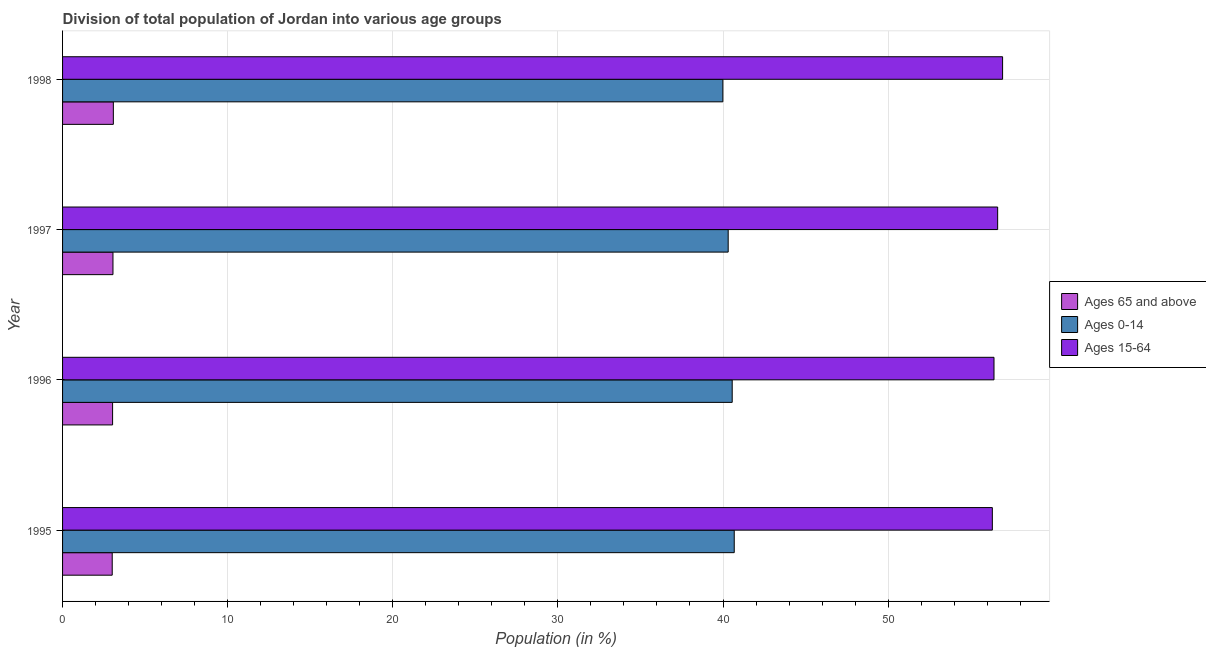Are the number of bars per tick equal to the number of legend labels?
Keep it short and to the point. Yes. Are the number of bars on each tick of the Y-axis equal?
Your answer should be very brief. Yes. How many bars are there on the 1st tick from the top?
Your response must be concise. 3. What is the label of the 1st group of bars from the top?
Your response must be concise. 1998. In how many cases, is the number of bars for a given year not equal to the number of legend labels?
Your response must be concise. 0. What is the percentage of population within the age-group 0-14 in 1995?
Make the answer very short. 40.68. Across all years, what is the maximum percentage of population within the age-group of 65 and above?
Keep it short and to the point. 3.08. Across all years, what is the minimum percentage of population within the age-group 0-14?
Ensure brevity in your answer.  39.99. In which year was the percentage of population within the age-group of 65 and above minimum?
Provide a succinct answer. 1995. What is the total percentage of population within the age-group of 65 and above in the graph?
Offer a terse response. 12.17. What is the difference between the percentage of population within the age-group 0-14 in 1995 and that in 1998?
Offer a very short reply. 0.69. What is the difference between the percentage of population within the age-group of 65 and above in 1996 and the percentage of population within the age-group 15-64 in 1995?
Make the answer very short. -53.28. What is the average percentage of population within the age-group 15-64 per year?
Keep it short and to the point. 56.57. In the year 1996, what is the difference between the percentage of population within the age-group 0-14 and percentage of population within the age-group 15-64?
Offer a terse response. -15.86. In how many years, is the percentage of population within the age-group 0-14 greater than 14 %?
Your answer should be very brief. 4. Is the percentage of population within the age-group 15-64 in 1996 less than that in 1997?
Offer a very short reply. Yes. Is the difference between the percentage of population within the age-group 0-14 in 1995 and 1998 greater than the difference between the percentage of population within the age-group of 65 and above in 1995 and 1998?
Keep it short and to the point. Yes. What is the difference between the highest and the second highest percentage of population within the age-group of 65 and above?
Give a very brief answer. 0.02. What is the difference between the highest and the lowest percentage of population within the age-group 15-64?
Make the answer very short. 0.62. What does the 3rd bar from the top in 1996 represents?
Ensure brevity in your answer.  Ages 65 and above. What does the 2nd bar from the bottom in 1995 represents?
Keep it short and to the point. Ages 0-14. Are all the bars in the graph horizontal?
Offer a terse response. Yes. How many years are there in the graph?
Keep it short and to the point. 4. Does the graph contain any zero values?
Make the answer very short. No. Where does the legend appear in the graph?
Your response must be concise. Center right. How many legend labels are there?
Provide a succinct answer. 3. What is the title of the graph?
Your response must be concise. Division of total population of Jordan into various age groups
. Does "Communicable diseases" appear as one of the legend labels in the graph?
Provide a short and direct response. No. What is the Population (in %) in Ages 65 and above in 1995?
Ensure brevity in your answer.  3.01. What is the Population (in %) in Ages 0-14 in 1995?
Make the answer very short. 40.68. What is the Population (in %) in Ages 15-64 in 1995?
Keep it short and to the point. 56.31. What is the Population (in %) of Ages 65 and above in 1996?
Offer a very short reply. 3.03. What is the Population (in %) of Ages 0-14 in 1996?
Offer a terse response. 40.56. What is the Population (in %) of Ages 15-64 in 1996?
Offer a terse response. 56.41. What is the Population (in %) of Ages 65 and above in 1997?
Offer a terse response. 3.05. What is the Population (in %) of Ages 0-14 in 1997?
Provide a succinct answer. 40.31. What is the Population (in %) of Ages 15-64 in 1997?
Your answer should be very brief. 56.63. What is the Population (in %) of Ages 65 and above in 1998?
Make the answer very short. 3.08. What is the Population (in %) in Ages 0-14 in 1998?
Ensure brevity in your answer.  39.99. What is the Population (in %) in Ages 15-64 in 1998?
Provide a succinct answer. 56.93. Across all years, what is the maximum Population (in %) of Ages 65 and above?
Provide a short and direct response. 3.08. Across all years, what is the maximum Population (in %) of Ages 0-14?
Offer a terse response. 40.68. Across all years, what is the maximum Population (in %) of Ages 15-64?
Your answer should be compact. 56.93. Across all years, what is the minimum Population (in %) of Ages 65 and above?
Ensure brevity in your answer.  3.01. Across all years, what is the minimum Population (in %) in Ages 0-14?
Offer a very short reply. 39.99. Across all years, what is the minimum Population (in %) in Ages 15-64?
Keep it short and to the point. 56.31. What is the total Population (in %) of Ages 65 and above in the graph?
Keep it short and to the point. 12.17. What is the total Population (in %) of Ages 0-14 in the graph?
Provide a succinct answer. 161.54. What is the total Population (in %) in Ages 15-64 in the graph?
Your answer should be compact. 226.29. What is the difference between the Population (in %) of Ages 65 and above in 1995 and that in 1996?
Offer a terse response. -0.02. What is the difference between the Population (in %) in Ages 0-14 in 1995 and that in 1996?
Offer a terse response. 0.12. What is the difference between the Population (in %) in Ages 15-64 in 1995 and that in 1996?
Ensure brevity in your answer.  -0.1. What is the difference between the Population (in %) in Ages 65 and above in 1995 and that in 1997?
Provide a succinct answer. -0.04. What is the difference between the Population (in %) in Ages 0-14 in 1995 and that in 1997?
Ensure brevity in your answer.  0.37. What is the difference between the Population (in %) of Ages 15-64 in 1995 and that in 1997?
Your answer should be very brief. -0.32. What is the difference between the Population (in %) of Ages 65 and above in 1995 and that in 1998?
Provide a short and direct response. -0.07. What is the difference between the Population (in %) in Ages 0-14 in 1995 and that in 1998?
Keep it short and to the point. 0.69. What is the difference between the Population (in %) in Ages 15-64 in 1995 and that in 1998?
Make the answer very short. -0.62. What is the difference between the Population (in %) of Ages 65 and above in 1996 and that in 1997?
Provide a short and direct response. -0.02. What is the difference between the Population (in %) in Ages 0-14 in 1996 and that in 1997?
Ensure brevity in your answer.  0.24. What is the difference between the Population (in %) of Ages 15-64 in 1996 and that in 1997?
Give a very brief answer. -0.22. What is the difference between the Population (in %) of Ages 65 and above in 1996 and that in 1998?
Ensure brevity in your answer.  -0.05. What is the difference between the Population (in %) in Ages 0-14 in 1996 and that in 1998?
Your answer should be compact. 0.57. What is the difference between the Population (in %) in Ages 15-64 in 1996 and that in 1998?
Give a very brief answer. -0.52. What is the difference between the Population (in %) in Ages 65 and above in 1997 and that in 1998?
Give a very brief answer. -0.02. What is the difference between the Population (in %) in Ages 0-14 in 1997 and that in 1998?
Provide a succinct answer. 0.32. What is the difference between the Population (in %) in Ages 15-64 in 1997 and that in 1998?
Give a very brief answer. -0.3. What is the difference between the Population (in %) in Ages 65 and above in 1995 and the Population (in %) in Ages 0-14 in 1996?
Make the answer very short. -37.55. What is the difference between the Population (in %) in Ages 65 and above in 1995 and the Population (in %) in Ages 15-64 in 1996?
Your response must be concise. -53.41. What is the difference between the Population (in %) in Ages 0-14 in 1995 and the Population (in %) in Ages 15-64 in 1996?
Ensure brevity in your answer.  -15.73. What is the difference between the Population (in %) in Ages 65 and above in 1995 and the Population (in %) in Ages 0-14 in 1997?
Provide a short and direct response. -37.31. What is the difference between the Population (in %) in Ages 65 and above in 1995 and the Population (in %) in Ages 15-64 in 1997?
Your response must be concise. -53.63. What is the difference between the Population (in %) in Ages 0-14 in 1995 and the Population (in %) in Ages 15-64 in 1997?
Keep it short and to the point. -15.95. What is the difference between the Population (in %) in Ages 65 and above in 1995 and the Population (in %) in Ages 0-14 in 1998?
Your answer should be very brief. -36.98. What is the difference between the Population (in %) in Ages 65 and above in 1995 and the Population (in %) in Ages 15-64 in 1998?
Your answer should be very brief. -53.93. What is the difference between the Population (in %) in Ages 0-14 in 1995 and the Population (in %) in Ages 15-64 in 1998?
Make the answer very short. -16.25. What is the difference between the Population (in %) in Ages 65 and above in 1996 and the Population (in %) in Ages 0-14 in 1997?
Make the answer very short. -37.28. What is the difference between the Population (in %) in Ages 65 and above in 1996 and the Population (in %) in Ages 15-64 in 1997?
Keep it short and to the point. -53.6. What is the difference between the Population (in %) in Ages 0-14 in 1996 and the Population (in %) in Ages 15-64 in 1997?
Make the answer very short. -16.08. What is the difference between the Population (in %) of Ages 65 and above in 1996 and the Population (in %) of Ages 0-14 in 1998?
Your response must be concise. -36.96. What is the difference between the Population (in %) of Ages 65 and above in 1996 and the Population (in %) of Ages 15-64 in 1998?
Your response must be concise. -53.9. What is the difference between the Population (in %) of Ages 0-14 in 1996 and the Population (in %) of Ages 15-64 in 1998?
Your answer should be very brief. -16.38. What is the difference between the Population (in %) in Ages 65 and above in 1997 and the Population (in %) in Ages 0-14 in 1998?
Give a very brief answer. -36.94. What is the difference between the Population (in %) in Ages 65 and above in 1997 and the Population (in %) in Ages 15-64 in 1998?
Your response must be concise. -53.88. What is the difference between the Population (in %) in Ages 0-14 in 1997 and the Population (in %) in Ages 15-64 in 1998?
Ensure brevity in your answer.  -16.62. What is the average Population (in %) in Ages 65 and above per year?
Offer a terse response. 3.04. What is the average Population (in %) in Ages 0-14 per year?
Offer a terse response. 40.39. What is the average Population (in %) of Ages 15-64 per year?
Keep it short and to the point. 56.57. In the year 1995, what is the difference between the Population (in %) of Ages 65 and above and Population (in %) of Ages 0-14?
Provide a succinct answer. -37.67. In the year 1995, what is the difference between the Population (in %) of Ages 65 and above and Population (in %) of Ages 15-64?
Keep it short and to the point. -53.31. In the year 1995, what is the difference between the Population (in %) in Ages 0-14 and Population (in %) in Ages 15-64?
Offer a very short reply. -15.63. In the year 1996, what is the difference between the Population (in %) in Ages 65 and above and Population (in %) in Ages 0-14?
Offer a terse response. -37.53. In the year 1996, what is the difference between the Population (in %) in Ages 65 and above and Population (in %) in Ages 15-64?
Ensure brevity in your answer.  -53.38. In the year 1996, what is the difference between the Population (in %) of Ages 0-14 and Population (in %) of Ages 15-64?
Make the answer very short. -15.86. In the year 1997, what is the difference between the Population (in %) of Ages 65 and above and Population (in %) of Ages 0-14?
Provide a short and direct response. -37.26. In the year 1997, what is the difference between the Population (in %) in Ages 65 and above and Population (in %) in Ages 15-64?
Make the answer very short. -53.58. In the year 1997, what is the difference between the Population (in %) of Ages 0-14 and Population (in %) of Ages 15-64?
Ensure brevity in your answer.  -16.32. In the year 1998, what is the difference between the Population (in %) of Ages 65 and above and Population (in %) of Ages 0-14?
Your response must be concise. -36.92. In the year 1998, what is the difference between the Population (in %) of Ages 65 and above and Population (in %) of Ages 15-64?
Your answer should be compact. -53.86. In the year 1998, what is the difference between the Population (in %) of Ages 0-14 and Population (in %) of Ages 15-64?
Give a very brief answer. -16.94. What is the ratio of the Population (in %) of Ages 0-14 in 1995 to that in 1997?
Give a very brief answer. 1.01. What is the ratio of the Population (in %) of Ages 15-64 in 1995 to that in 1997?
Give a very brief answer. 0.99. What is the ratio of the Population (in %) in Ages 0-14 in 1995 to that in 1998?
Provide a short and direct response. 1.02. What is the ratio of the Population (in %) of Ages 15-64 in 1995 to that in 1998?
Offer a terse response. 0.99. What is the ratio of the Population (in %) of Ages 65 and above in 1996 to that in 1997?
Your response must be concise. 0.99. What is the ratio of the Population (in %) of Ages 15-64 in 1996 to that in 1997?
Make the answer very short. 1. What is the ratio of the Population (in %) of Ages 65 and above in 1996 to that in 1998?
Your answer should be very brief. 0.99. What is the ratio of the Population (in %) in Ages 0-14 in 1996 to that in 1998?
Your response must be concise. 1.01. What is the ratio of the Population (in %) of Ages 15-64 in 1996 to that in 1998?
Offer a terse response. 0.99. What is the ratio of the Population (in %) of Ages 0-14 in 1997 to that in 1998?
Your answer should be compact. 1.01. What is the difference between the highest and the second highest Population (in %) in Ages 65 and above?
Your response must be concise. 0.02. What is the difference between the highest and the second highest Population (in %) of Ages 0-14?
Provide a short and direct response. 0.12. What is the difference between the highest and the second highest Population (in %) in Ages 15-64?
Offer a very short reply. 0.3. What is the difference between the highest and the lowest Population (in %) of Ages 65 and above?
Provide a succinct answer. 0.07. What is the difference between the highest and the lowest Population (in %) of Ages 0-14?
Provide a short and direct response. 0.69. What is the difference between the highest and the lowest Population (in %) in Ages 15-64?
Your answer should be compact. 0.62. 